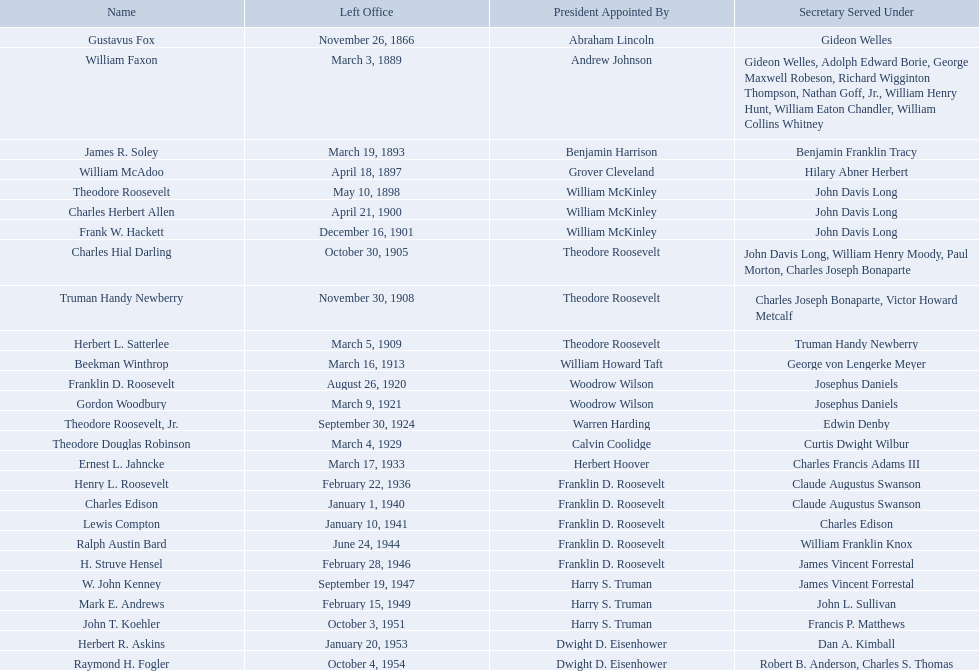Who were all the assistant secretary's of the navy? Gustavus Fox, William Faxon, James R. Soley, William McAdoo, Theodore Roosevelt, Charles Herbert Allen, Frank W. Hackett, Charles Hial Darling, Truman Handy Newberry, Herbert L. Satterlee, Beekman Winthrop, Franklin D. Roosevelt, Gordon Woodbury, Theodore Roosevelt, Jr., Theodore Douglas Robinson, Ernest L. Jahncke, Henry L. Roosevelt, Charles Edison, Lewis Compton, Ralph Austin Bard, H. Struve Hensel, W. John Kenney, Mark E. Andrews, John T. Koehler, Herbert R. Askins, Raymond H. Fogler. What are the various dates they left office in? November 26, 1866, March 3, 1889, March 19, 1893, April 18, 1897, May 10, 1898, April 21, 1900, December 16, 1901, October 30, 1905, November 30, 1908, March 5, 1909, March 16, 1913, August 26, 1920, March 9, 1921, September 30, 1924, March 4, 1929, March 17, 1933, February 22, 1936, January 1, 1940, January 10, 1941, June 24, 1944, February 28, 1946, September 19, 1947, February 15, 1949, October 3, 1951, January 20, 1953, October 4, 1954. Of these dates, which was the date raymond h. fogler left office in? October 4, 1954. 